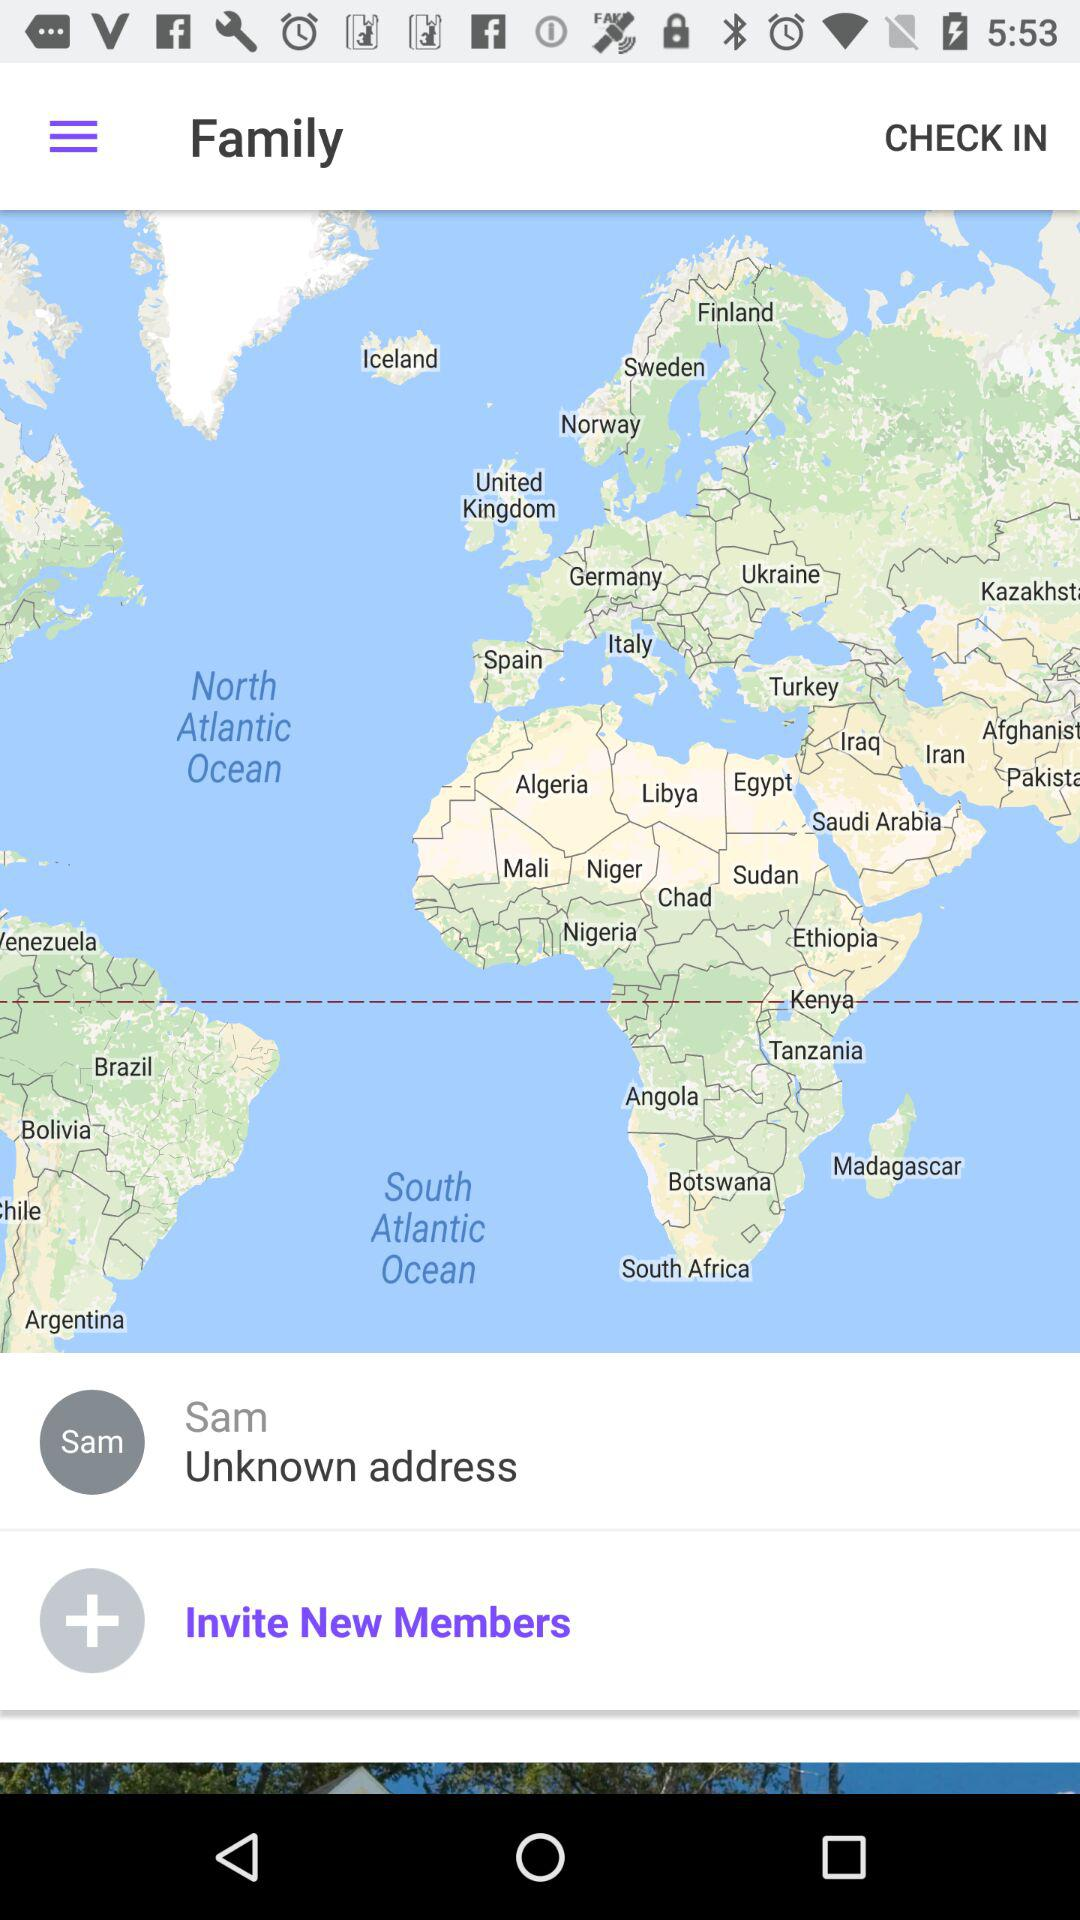What is the name of the user? The name of the user is Sam. 